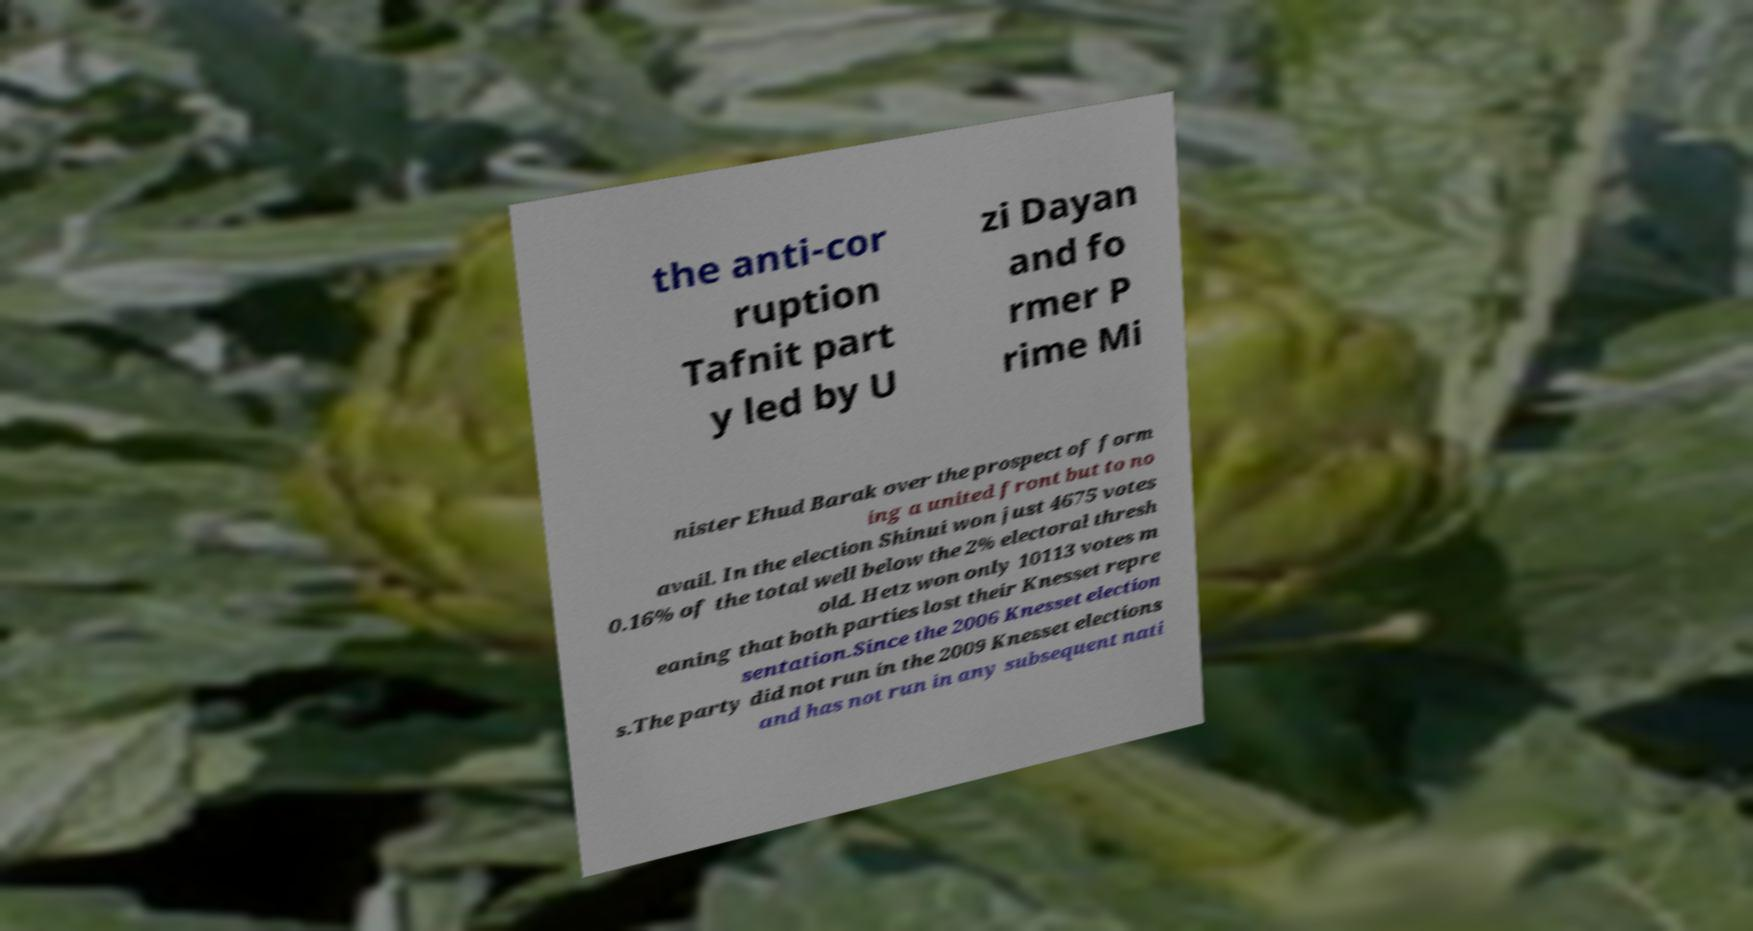Could you extract and type out the text from this image? the anti-cor ruption Tafnit part y led by U zi Dayan and fo rmer P rime Mi nister Ehud Barak over the prospect of form ing a united front but to no avail. In the election Shinui won just 4675 votes 0.16% of the total well below the 2% electoral thresh old. Hetz won only 10113 votes m eaning that both parties lost their Knesset repre sentation.Since the 2006 Knesset election s.The party did not run in the 2009 Knesset elections and has not run in any subsequent nati 